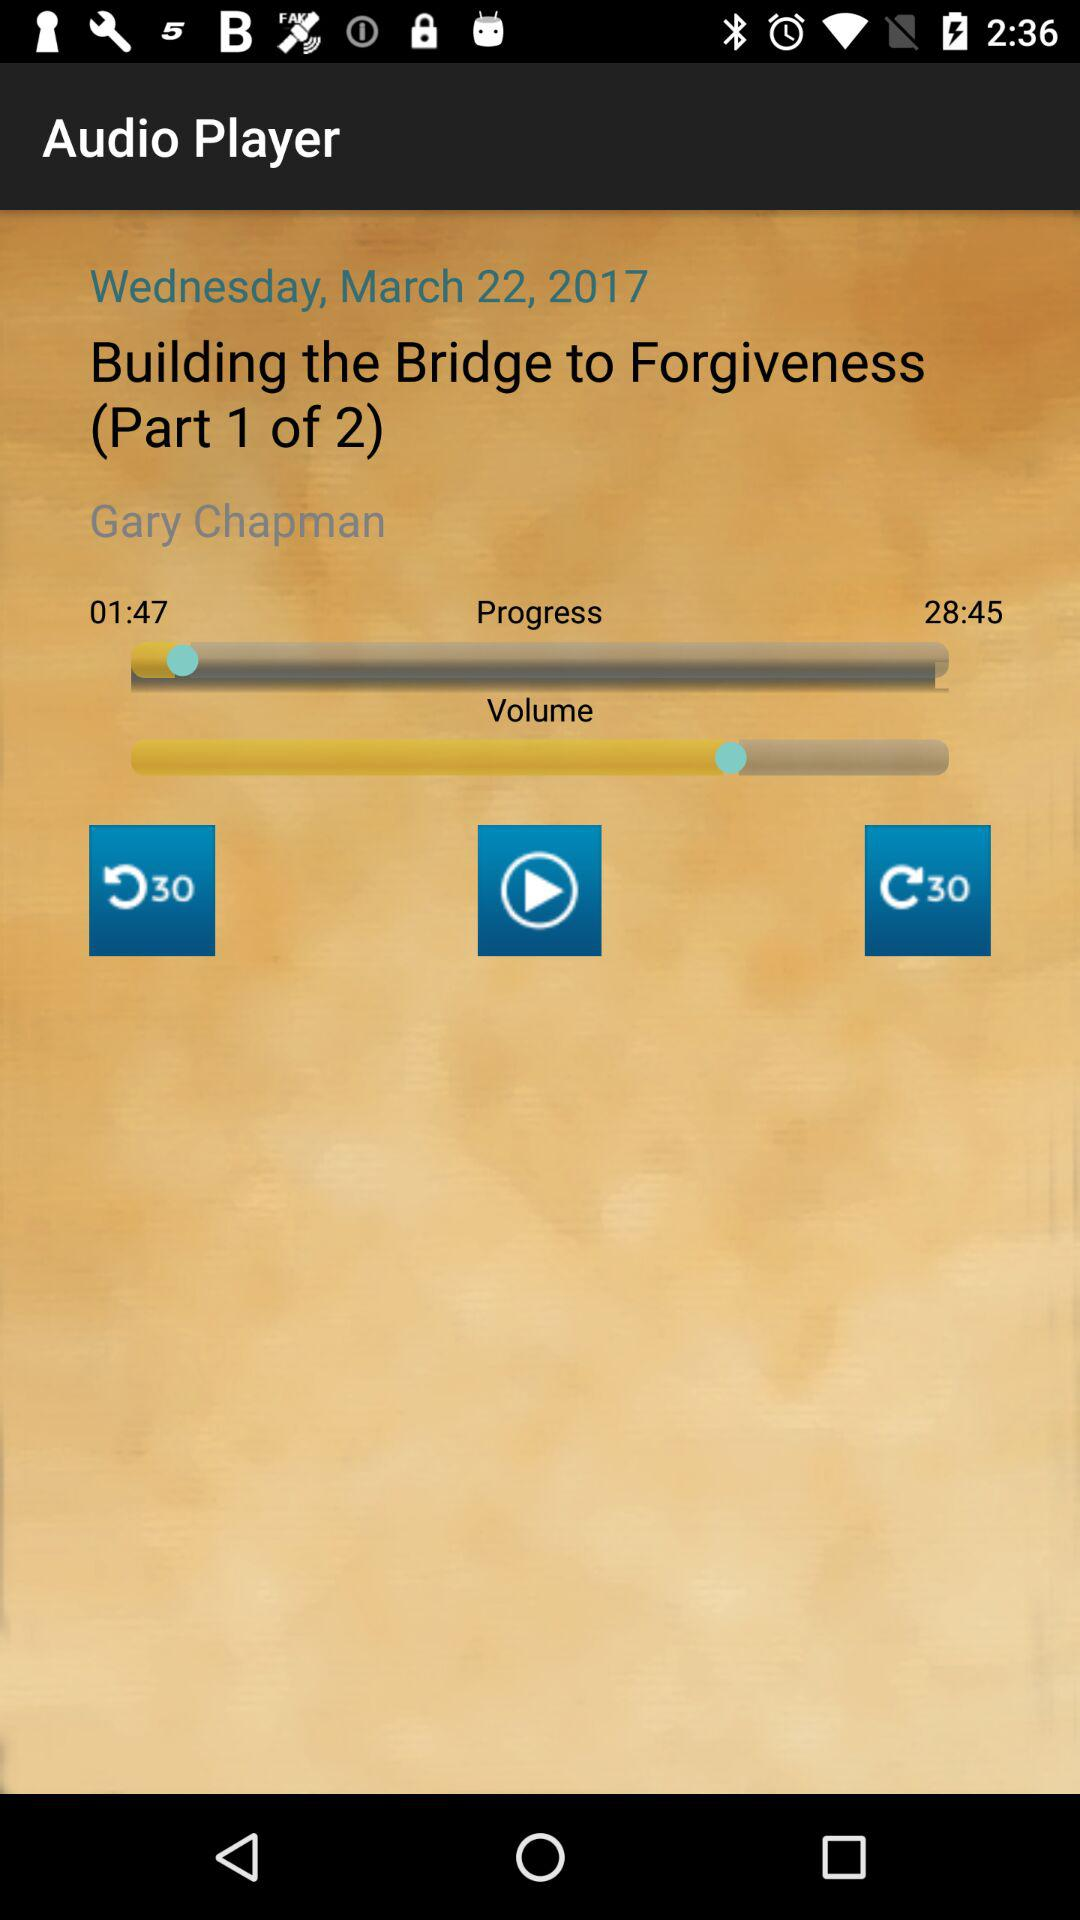How many parts are in "Building the Bridge to Forgiveness"? There are two parts. 